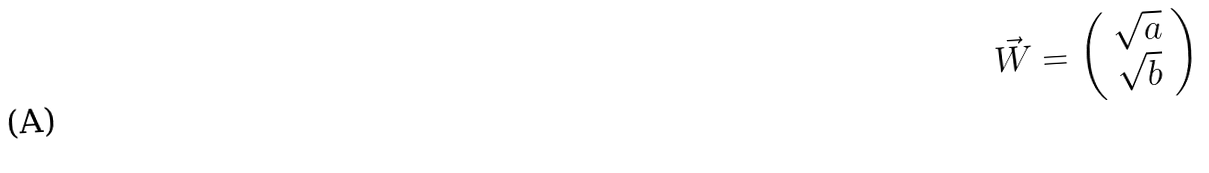Convert formula to latex. <formula><loc_0><loc_0><loc_500><loc_500>\vec { W } = \left ( \begin{array} { c } \sqrt { a } \\ \sqrt { b } \end{array} \right )</formula> 